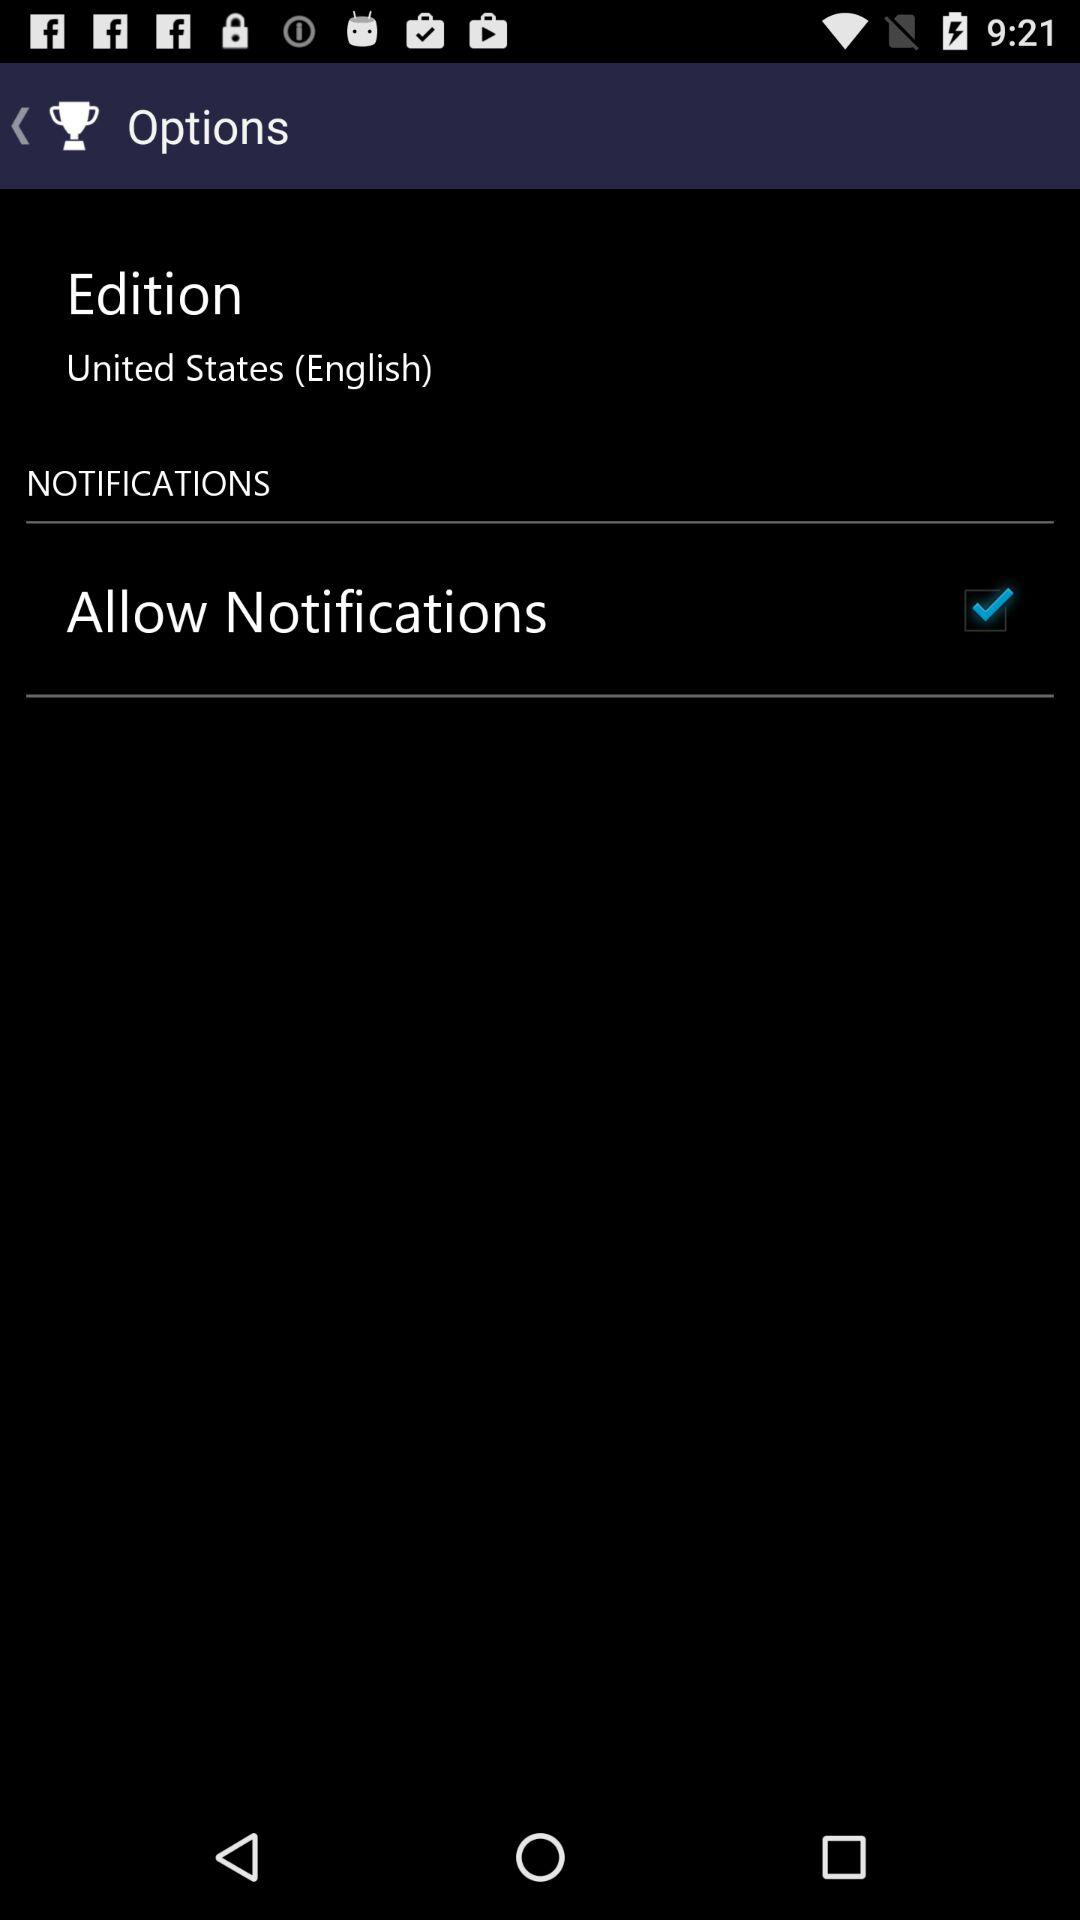What is the status of Allow Notifications? The status of Allow Notifications is on. 